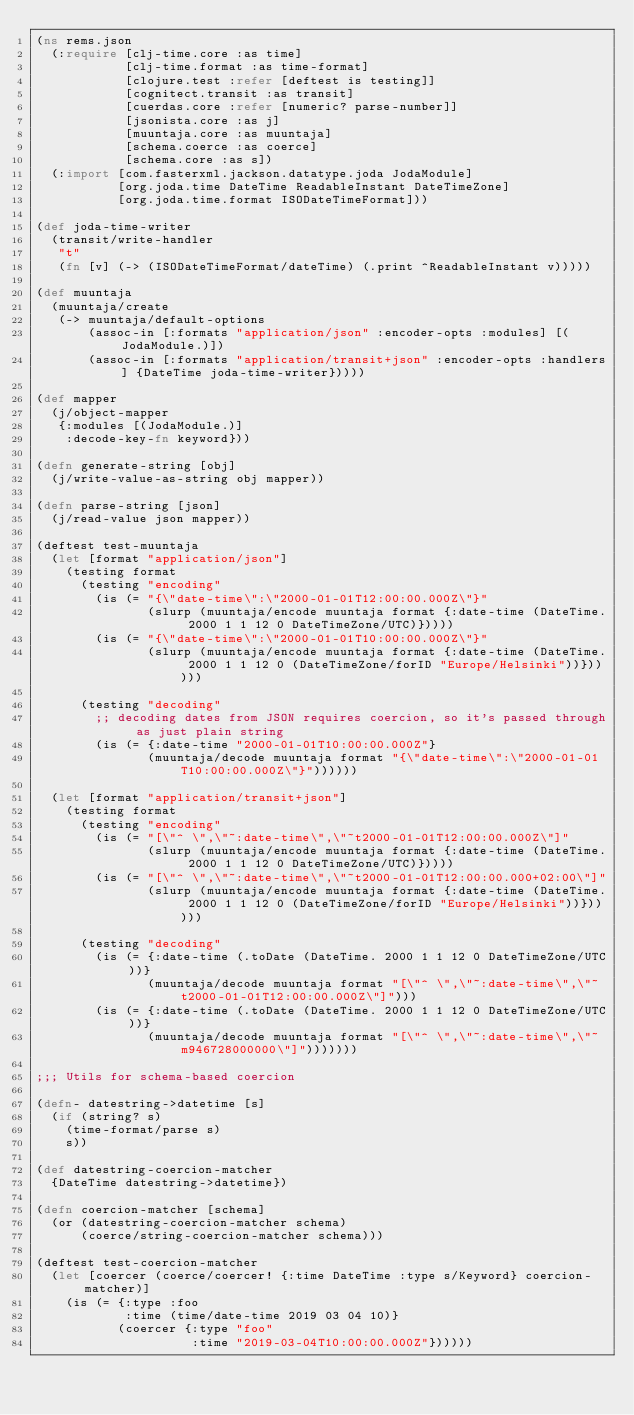Convert code to text. <code><loc_0><loc_0><loc_500><loc_500><_Clojure_>(ns rems.json
  (:require [clj-time.core :as time]
            [clj-time.format :as time-format]
            [clojure.test :refer [deftest is testing]]
            [cognitect.transit :as transit]
            [cuerdas.core :refer [numeric? parse-number]]
            [jsonista.core :as j]
            [muuntaja.core :as muuntaja]
            [schema.coerce :as coerce]
            [schema.core :as s])
  (:import [com.fasterxml.jackson.datatype.joda JodaModule]
           [org.joda.time DateTime ReadableInstant DateTimeZone]
           [org.joda.time.format ISODateTimeFormat]))

(def joda-time-writer
  (transit/write-handler
   "t"
   (fn [v] (-> (ISODateTimeFormat/dateTime) (.print ^ReadableInstant v)))))

(def muuntaja
  (muuntaja/create
   (-> muuntaja/default-options
       (assoc-in [:formats "application/json" :encoder-opts :modules] [(JodaModule.)])
       (assoc-in [:formats "application/transit+json" :encoder-opts :handlers] {DateTime joda-time-writer}))))

(def mapper
  (j/object-mapper
   {:modules [(JodaModule.)]
    :decode-key-fn keyword}))

(defn generate-string [obj]
  (j/write-value-as-string obj mapper))

(defn parse-string [json]
  (j/read-value json mapper))

(deftest test-muuntaja
  (let [format "application/json"]
    (testing format
      (testing "encoding"
        (is (= "{\"date-time\":\"2000-01-01T12:00:00.000Z\"}"
               (slurp (muuntaja/encode muuntaja format {:date-time (DateTime. 2000 1 1 12 0 DateTimeZone/UTC)}))))
        (is (= "{\"date-time\":\"2000-01-01T10:00:00.000Z\"}"
               (slurp (muuntaja/encode muuntaja format {:date-time (DateTime. 2000 1 1 12 0 (DateTimeZone/forID "Europe/Helsinki"))})))))

      (testing "decoding"
        ;; decoding dates from JSON requires coercion, so it's passed through as just plain string
        (is (= {:date-time "2000-01-01T10:00:00.000Z"}
               (muuntaja/decode muuntaja format "{\"date-time\":\"2000-01-01T10:00:00.000Z\"}"))))))

  (let [format "application/transit+json"]
    (testing format
      (testing "encoding"
        (is (= "[\"^ \",\"~:date-time\",\"~t2000-01-01T12:00:00.000Z\"]"
               (slurp (muuntaja/encode muuntaja format {:date-time (DateTime. 2000 1 1 12 0 DateTimeZone/UTC)}))))
        (is (= "[\"^ \",\"~:date-time\",\"~t2000-01-01T12:00:00.000+02:00\"]"
               (slurp (muuntaja/encode muuntaja format {:date-time (DateTime. 2000 1 1 12 0 (DateTimeZone/forID "Europe/Helsinki"))})))))

      (testing "decoding"
        (is (= {:date-time (.toDate (DateTime. 2000 1 1 12 0 DateTimeZone/UTC))}
               (muuntaja/decode muuntaja format "[\"^ \",\"~:date-time\",\"~t2000-01-01T12:00:00.000Z\"]")))
        (is (= {:date-time (.toDate (DateTime. 2000 1 1 12 0 DateTimeZone/UTC))}
               (muuntaja/decode muuntaja format "[\"^ \",\"~:date-time\",\"~m946728000000\"]")))))))

;;; Utils for schema-based coercion

(defn- datestring->datetime [s]
  (if (string? s)
    (time-format/parse s)
    s))

(def datestring-coercion-matcher
  {DateTime datestring->datetime})

(defn coercion-matcher [schema]
  (or (datestring-coercion-matcher schema)
      (coerce/string-coercion-matcher schema)))

(deftest test-coercion-matcher
  (let [coercer (coerce/coercer! {:time DateTime :type s/Keyword} coercion-matcher)]
    (is (= {:type :foo
            :time (time/date-time 2019 03 04 10)}
           (coercer {:type "foo"
                     :time "2019-03-04T10:00:00.000Z"})))))
</code> 